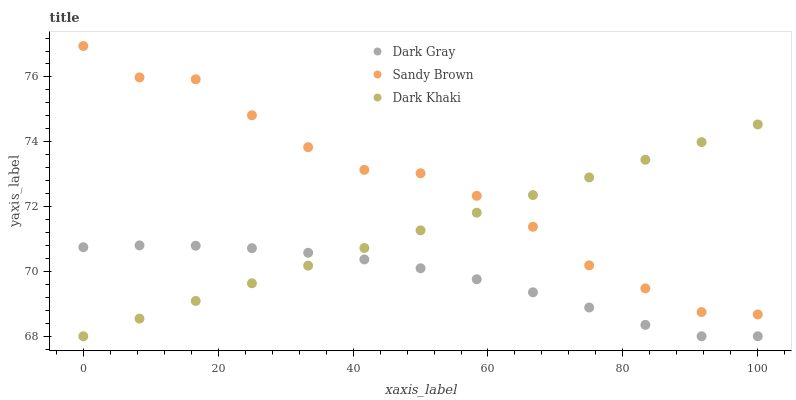Does Dark Gray have the minimum area under the curve?
Answer yes or no. Yes. Does Sandy Brown have the maximum area under the curve?
Answer yes or no. Yes. Does Dark Khaki have the minimum area under the curve?
Answer yes or no. No. Does Dark Khaki have the maximum area under the curve?
Answer yes or no. No. Is Dark Khaki the smoothest?
Answer yes or no. Yes. Is Sandy Brown the roughest?
Answer yes or no. Yes. Is Sandy Brown the smoothest?
Answer yes or no. No. Is Dark Khaki the roughest?
Answer yes or no. No. Does Dark Gray have the lowest value?
Answer yes or no. Yes. Does Sandy Brown have the lowest value?
Answer yes or no. No. Does Sandy Brown have the highest value?
Answer yes or no. Yes. Does Dark Khaki have the highest value?
Answer yes or no. No. Is Dark Gray less than Sandy Brown?
Answer yes or no. Yes. Is Sandy Brown greater than Dark Gray?
Answer yes or no. Yes. Does Dark Khaki intersect Dark Gray?
Answer yes or no. Yes. Is Dark Khaki less than Dark Gray?
Answer yes or no. No. Is Dark Khaki greater than Dark Gray?
Answer yes or no. No. Does Dark Gray intersect Sandy Brown?
Answer yes or no. No. 